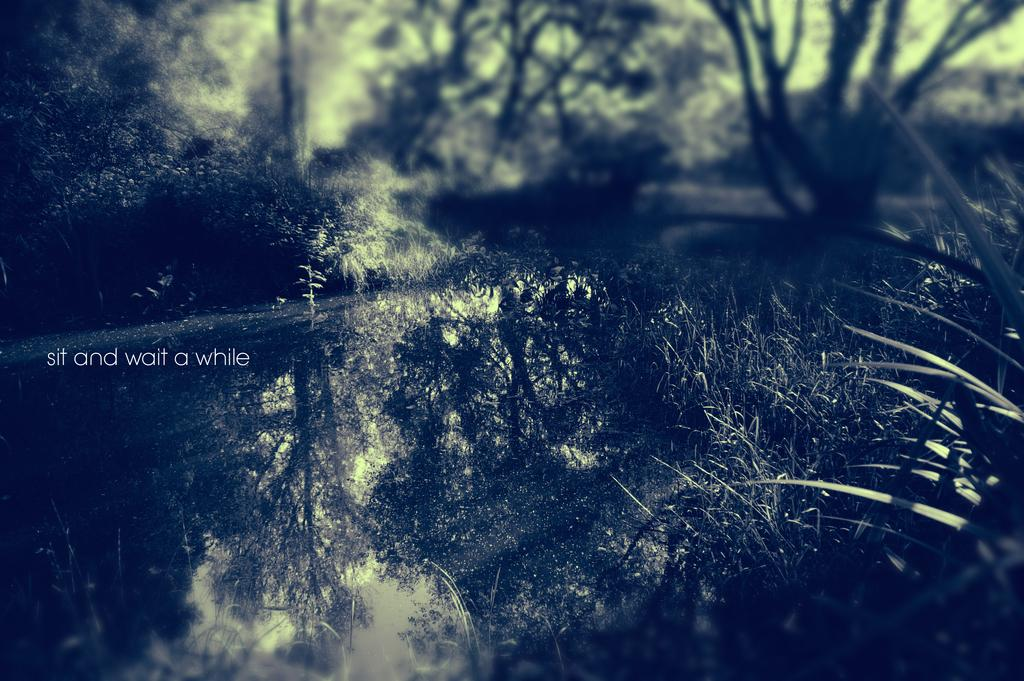What is located on the left side of the image? There is water and trees on the left side of the image. What type of vegetation is present on both sides of the image? There are trees on both the left and right sides of the image. What other type of plant can be seen on the right side of the image? Small plants are visible on the right side of the image. What type of poison is being used by the trees on the right side of the image? There is no mention of poison in the image, and the trees do not appear to be using any. What season is depicted in the image, considering the presence of trees and small plants? The image does not provide enough information to determine the season, as trees and small plants can be present in various seasons. 